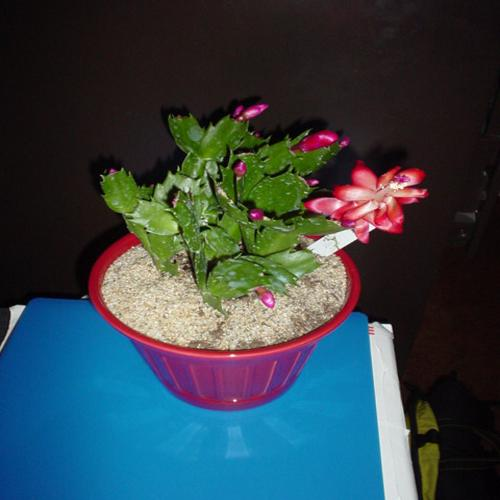What is the subject of the image?
A. A potted cactus.
B. A hanging basket.
C. A succulent plant.
D. A flowering plant.
Answer with the option's letter from the given choices directly. The subject of the image is a potted flowering plant, specifically a Christmas cactus with its distinctive segmented leaves and vibrant pink blossoms. It is in full bloom, indicating that the photo was likely taken during its blooming season, which is typically around the winter holidays. 